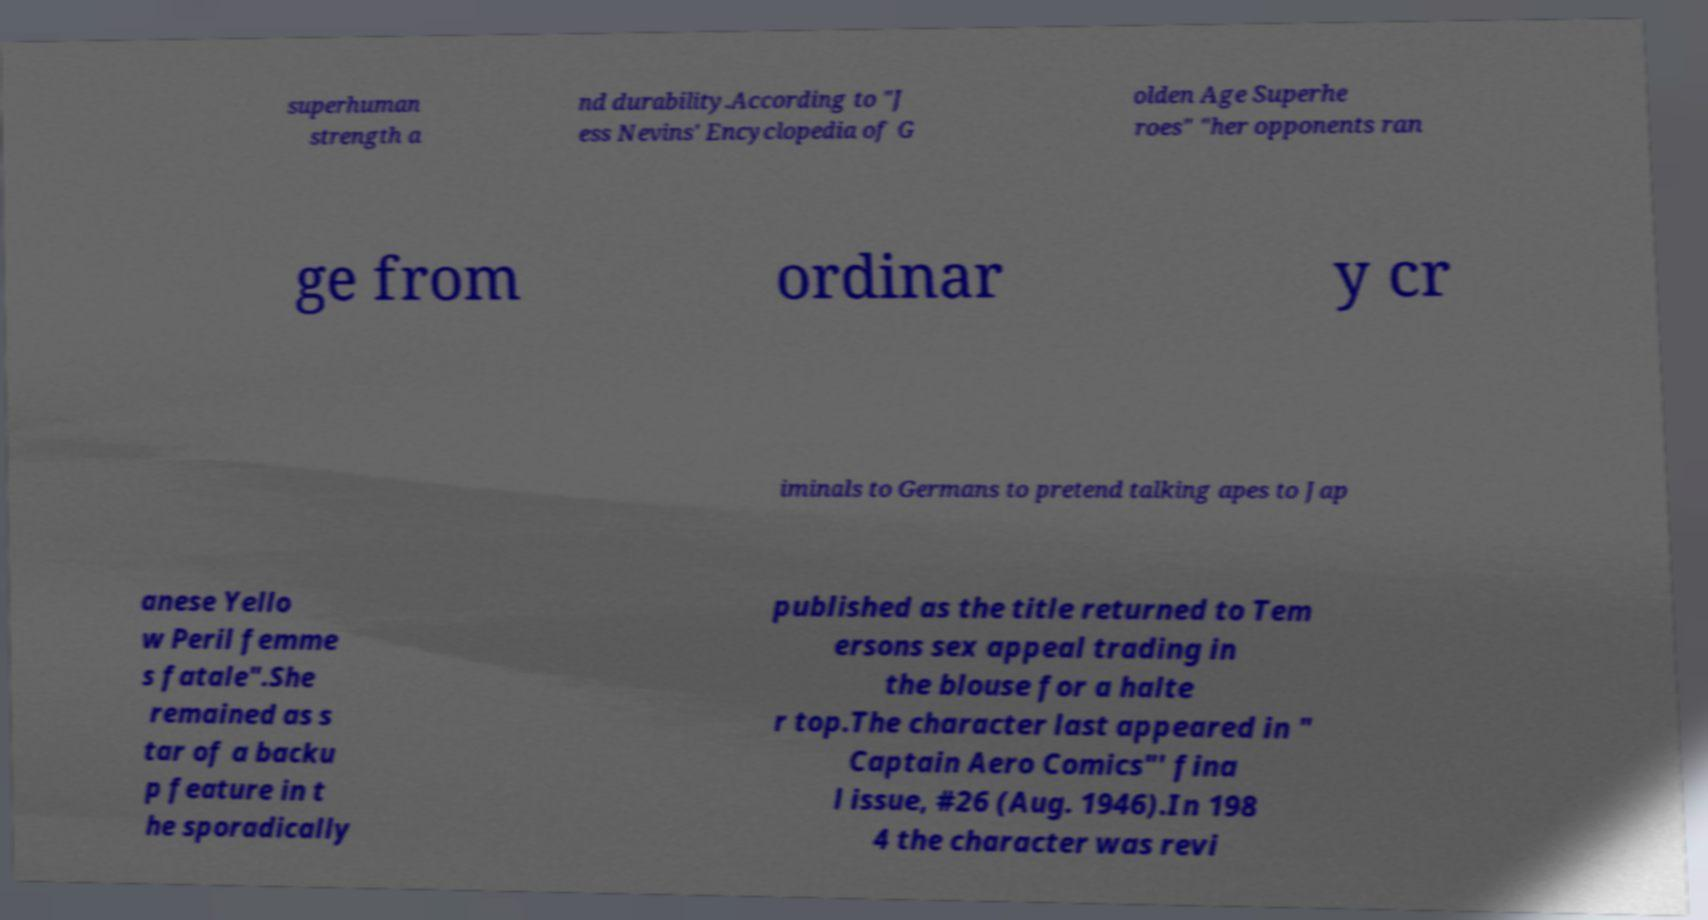Please identify and transcribe the text found in this image. superhuman strength a nd durability.According to "J ess Nevins' Encyclopedia of G olden Age Superhe roes" "her opponents ran ge from ordinar y cr iminals to Germans to pretend talking apes to Jap anese Yello w Peril femme s fatale".She remained as s tar of a backu p feature in t he sporadically published as the title returned to Tem ersons sex appeal trading in the blouse for a halte r top.The character last appeared in " Captain Aero Comics"' fina l issue, #26 (Aug. 1946).In 198 4 the character was revi 